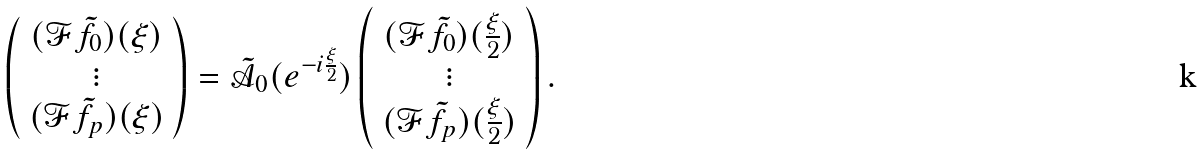<formula> <loc_0><loc_0><loc_500><loc_500>\left ( \begin{array} { c } ( \mathcal { F } \tilde { f } _ { 0 } ) ( \xi ) \\ \vdots \\ ( \mathcal { F } \tilde { f } _ { p } ) ( \xi ) \end{array} \right ) = \tilde { \mathcal { A } } _ { 0 } ( e ^ { - i \frac { \xi } { 2 } } ) \left ( \begin{array} { c } ( \mathcal { F } \tilde { f } _ { 0 } ) ( \frac { \xi } { 2 } ) \\ \vdots \\ ( \mathcal { F } \tilde { f } _ { p } ) ( \frac { \xi } { 2 } ) \end{array} \right ) .</formula> 